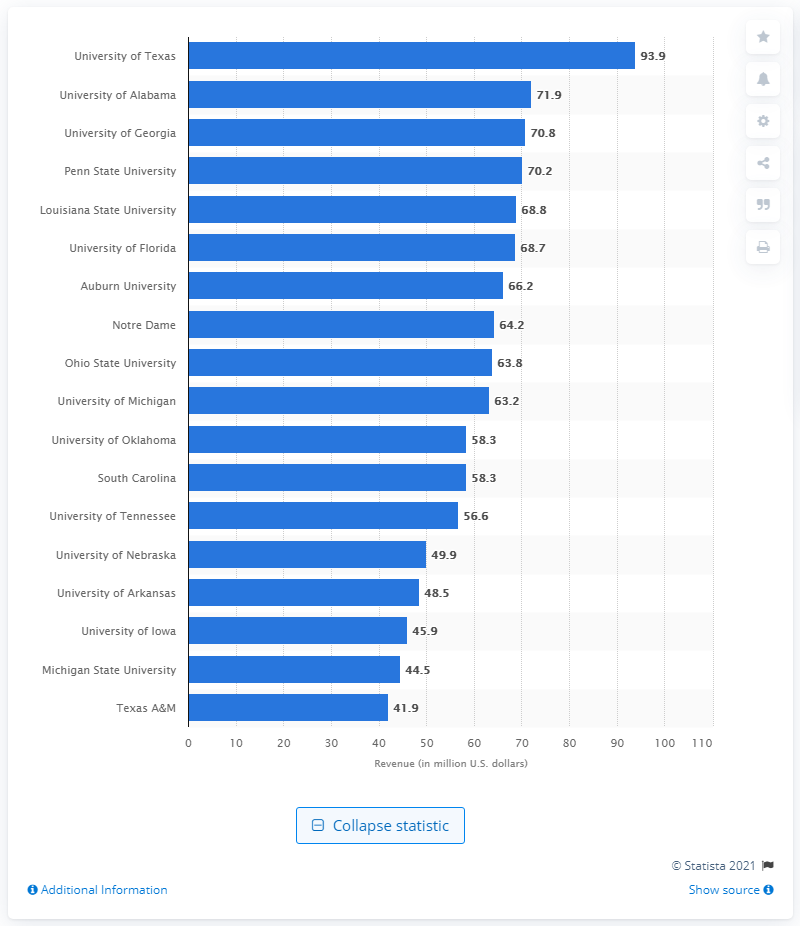Can you tell me how many universities on this chart have revenues higher than 60 million U.S. dollars? There are eight universities on the chart with revenues higher than 60 million U.S. dollars. 